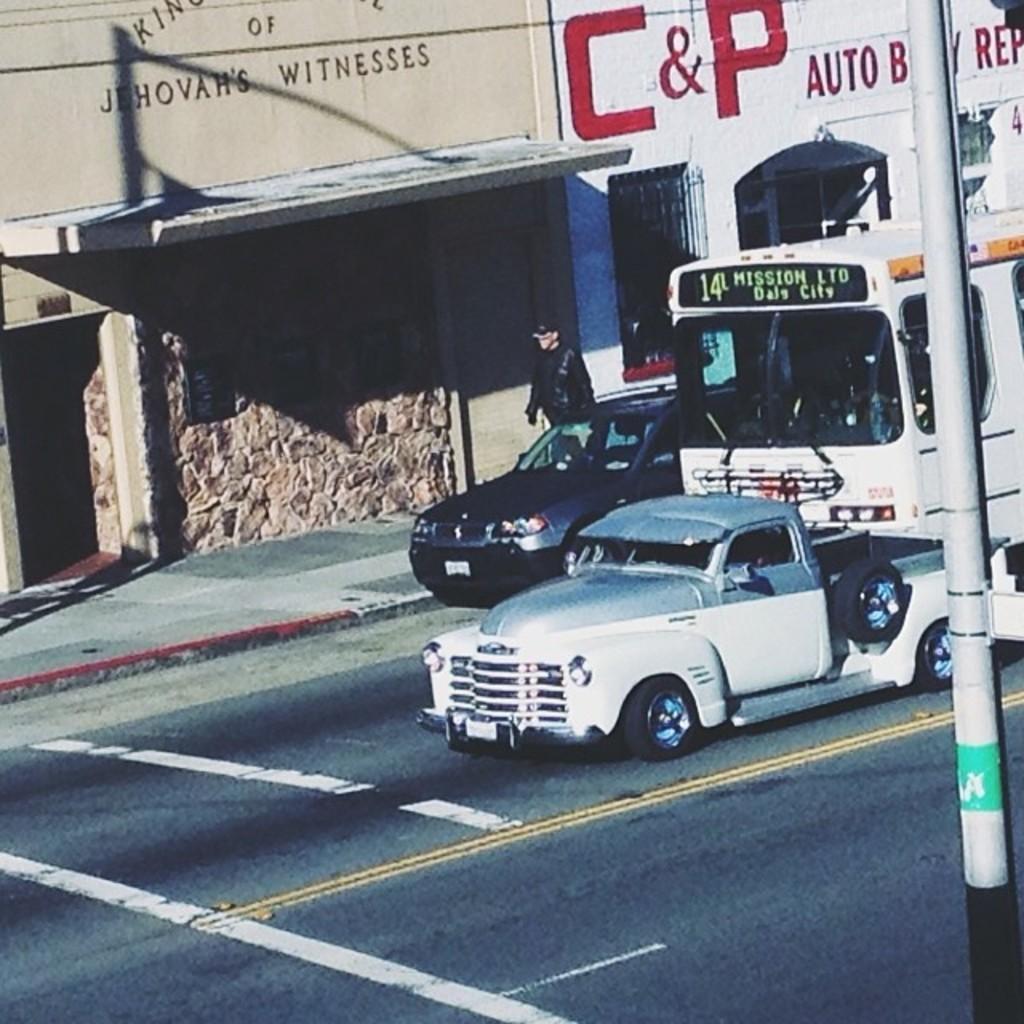How would you summarize this image in a sentence or two? There are some vehicles moving on this road in this picture. We can observe two cars and a bus. On the right side there is a pole. There is a person walking on the footpath. In the background there is a wall. 